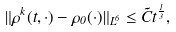<formula> <loc_0><loc_0><loc_500><loc_500>\| \rho ^ { k } ( t , \cdot ) - \rho _ { 0 } ( \cdot ) \| _ { L ^ { 6 } } \leq \tilde { C } t ^ { \frac { 1 } { 3 } } ,</formula> 